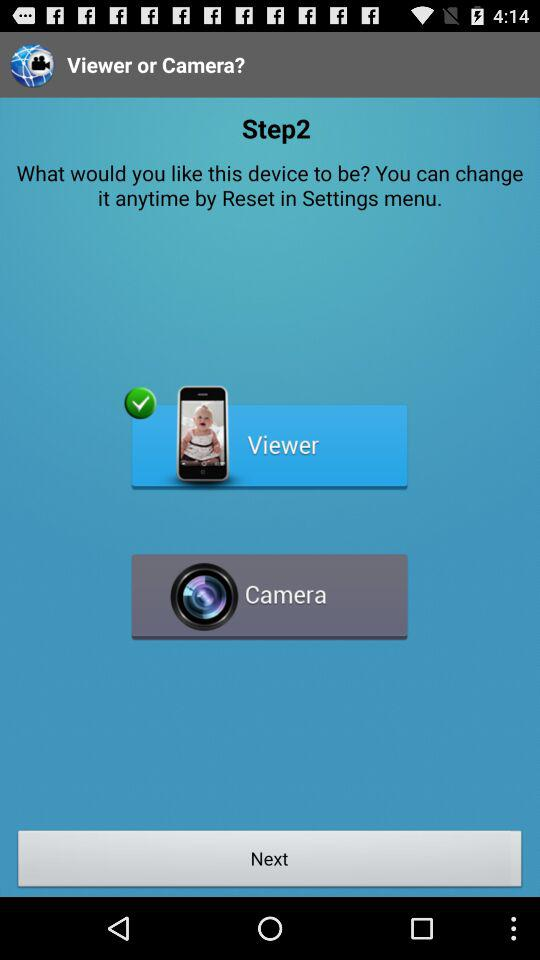Which option is selected? The selected option is "Viewer". 